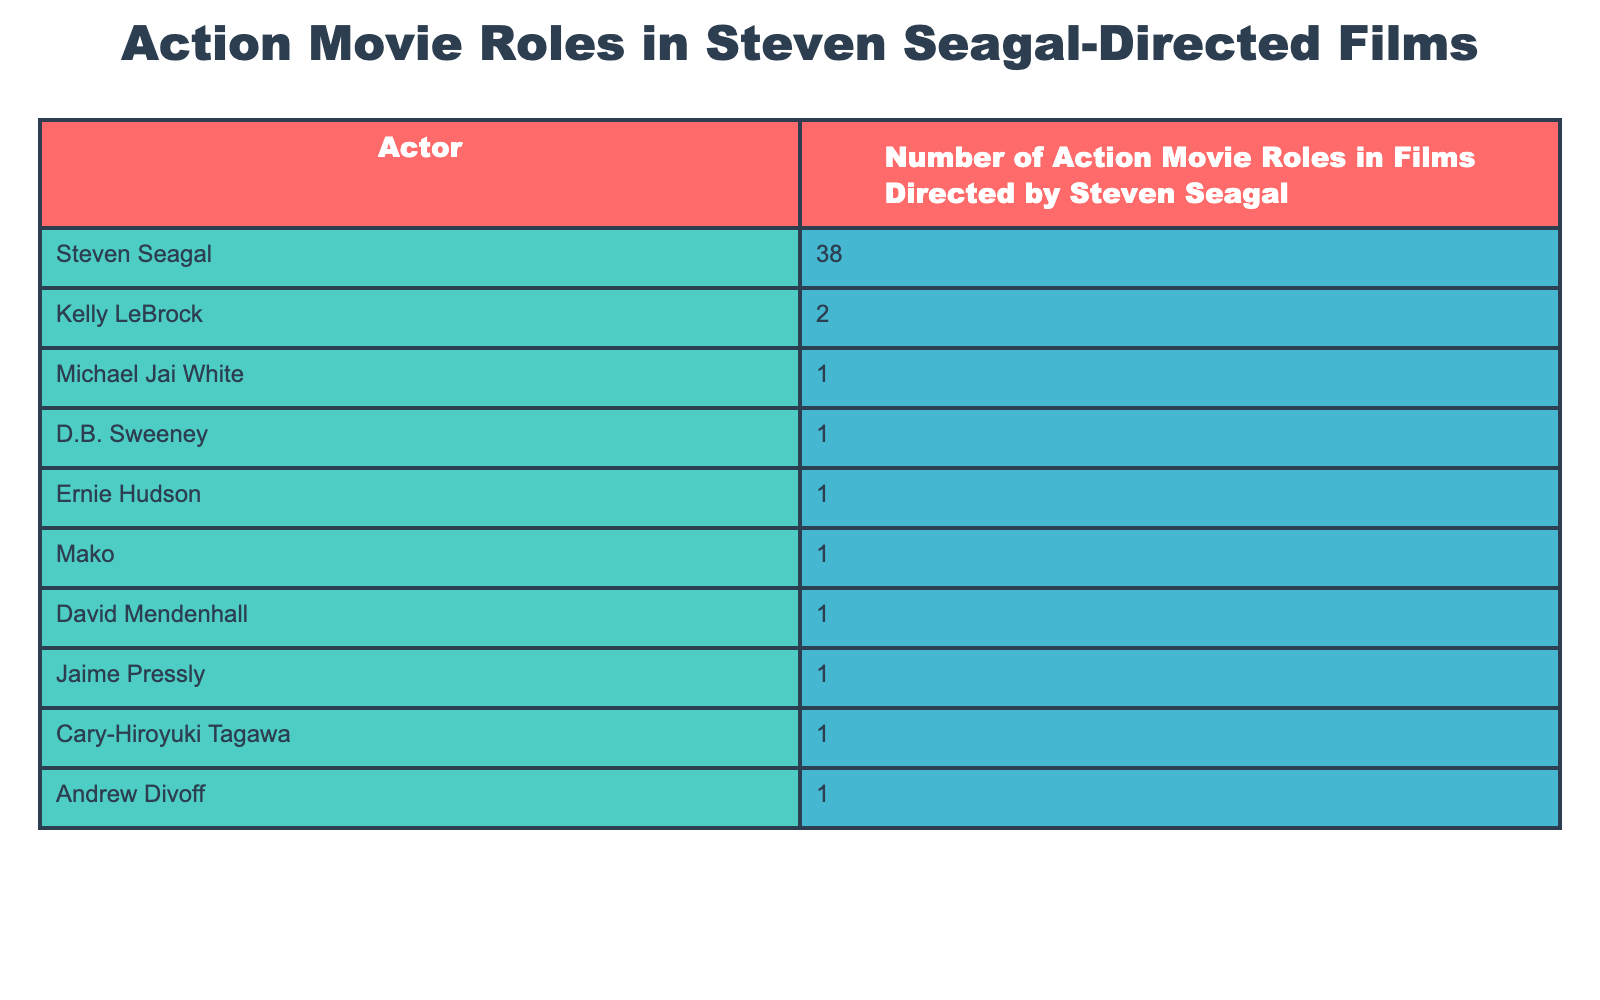What is the total number of action movie roles among the actors listed? To find the total, we add the number of roles for each actor: 38 (Steven Seagal) + 2 (Kelly LeBrock) + 1 (Michael Jai White) + 1 (D.B. Sweeney) + 1 (Ernie Hudson) + 1 (Mako) + 1 (David Mendenhall) + 1 (Jaime Pressly) + 1 (Cary-Hiroyuki Tagawa) + 1 (Andrew Divoff) = 48.
Answer: 48 Which actor has the highest number of action movie roles in Seagal-directed films? The actor with the highest number of roles is Steven Seagal, who has 38 roles, as seen at the top of the table.
Answer: Steven Seagal How many actors have exactly 1 action movie role in Seagal-directed films? There are 7 actors (Michael Jai White, D.B. Sweeney, Ernie Hudson, Mako, David Mendenhall, Jaime Pressly, Cary-Hiroyuki Tagawa, and Andrew Divoff) with exactly 1 role, which can be counted directly from the table.
Answer: 7 What percentage of the total action movie roles does Steven Seagal represent? First, calculate the percentage: (38/48) * 100 = 79.17%. So, Steven Seagal represents about 79.17% of the total roles when rounded to two decimal places.
Answer: 79.17% Is there any actor in the table who has more than 5 action movie roles? Based on the table, the only actor with more than 5 roles is Steven Seagal, who has 38.
Answer: Yes How many more action movie roles does Steven Seagal have compared to Kelly LeBrock? Calculate the difference: 38 (Steven Seagal) - 2 (Kelly LeBrock) = 36. So, he has 36 more roles than her.
Answer: 36 What is the average number of action movie roles per actor listed in the table? To find the average, sum the roles for all actors (48) and divide by the number of actors (10): 48 / 10 = 4.8.
Answer: 4.8 Which actor has the fewest action movie roles in Seagal-directed films? The actors with the fewest roles all have 1, and there are 7 of them (listed in the table).
Answer: 1 (multiple actors) What is the total number of action movie roles from actors who are not Steven Seagal? Add the roles of the other actors: 2 (Kelly LeBrock) + 1 (Michael Jai White) + 1 (D.B. Sweeney) + 1 (Ernie Hudson) + 1 (Mako) + 1 (David Mendenhall) + 1 (Jaime Pressly) + 1 (Cary-Hiroyuki Tagawa) + 1 (Andrew Divoff) = 10.
Answer: 10 How many actors have roles totaling less than 3 in Seagal-directed films? The only actor with roles totaling less than 3 (which is 0, 1, or 2) are Kelly LeBrock and those with 1 role. Thus, 8 actors (Kelly LeBrock and the 7 with 1 role) total less than 3.
Answer: 8 